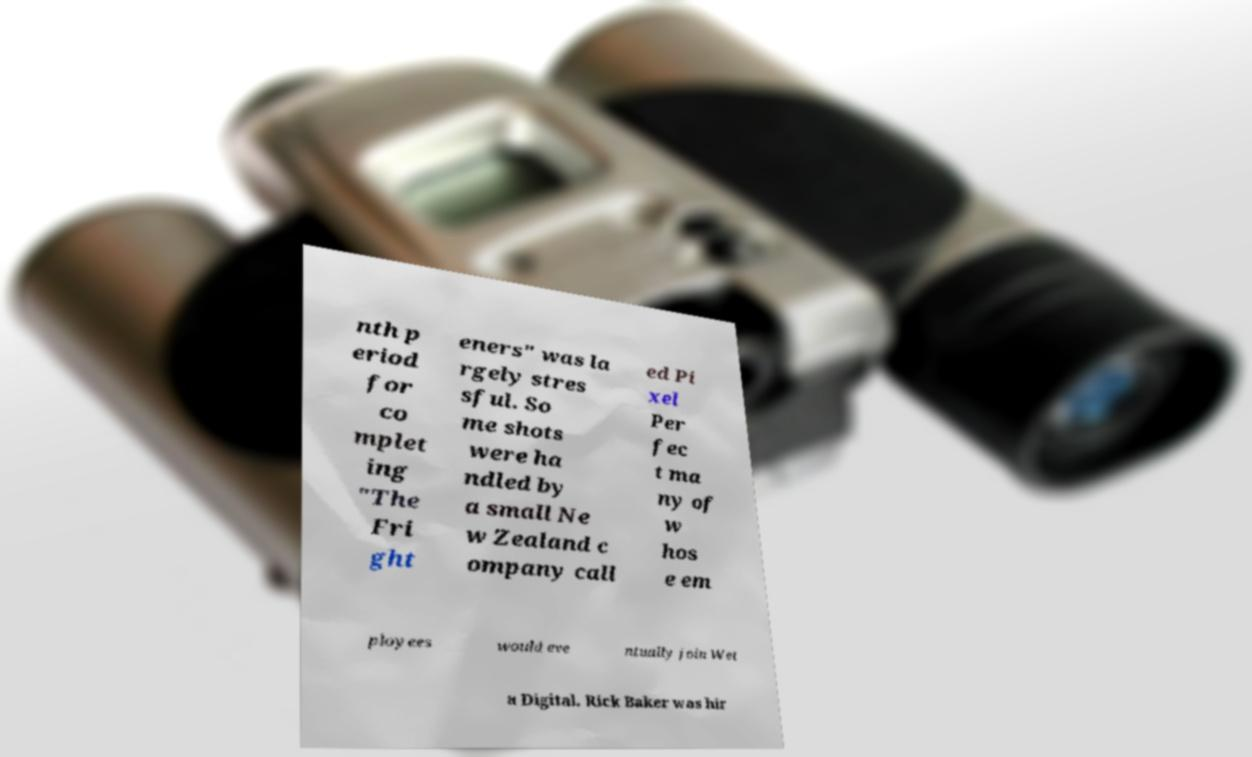Could you assist in decoding the text presented in this image and type it out clearly? nth p eriod for co mplet ing "The Fri ght eners" was la rgely stres sful. So me shots were ha ndled by a small Ne w Zealand c ompany call ed Pi xel Per fec t ma ny of w hos e em ployees would eve ntually join Wet a Digital. Rick Baker was hir 